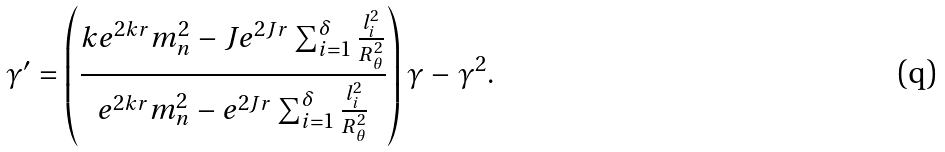<formula> <loc_0><loc_0><loc_500><loc_500>\gamma ^ { \prime } = \left ( \frac { k e ^ { 2 k r } m _ { n } ^ { 2 } - J e ^ { 2 J r } \sum _ { i = 1 } ^ { \delta } \frac { l _ { i } ^ { 2 } } { R _ { \theta } ^ { 2 } } } { e ^ { 2 k r } m _ { n } ^ { 2 } - e ^ { 2 J r } \sum _ { i = 1 } ^ { \delta } \frac { l _ { i } ^ { 2 } } { R _ { \theta } ^ { 2 } } } \right ) \gamma - \gamma ^ { 2 } .</formula> 